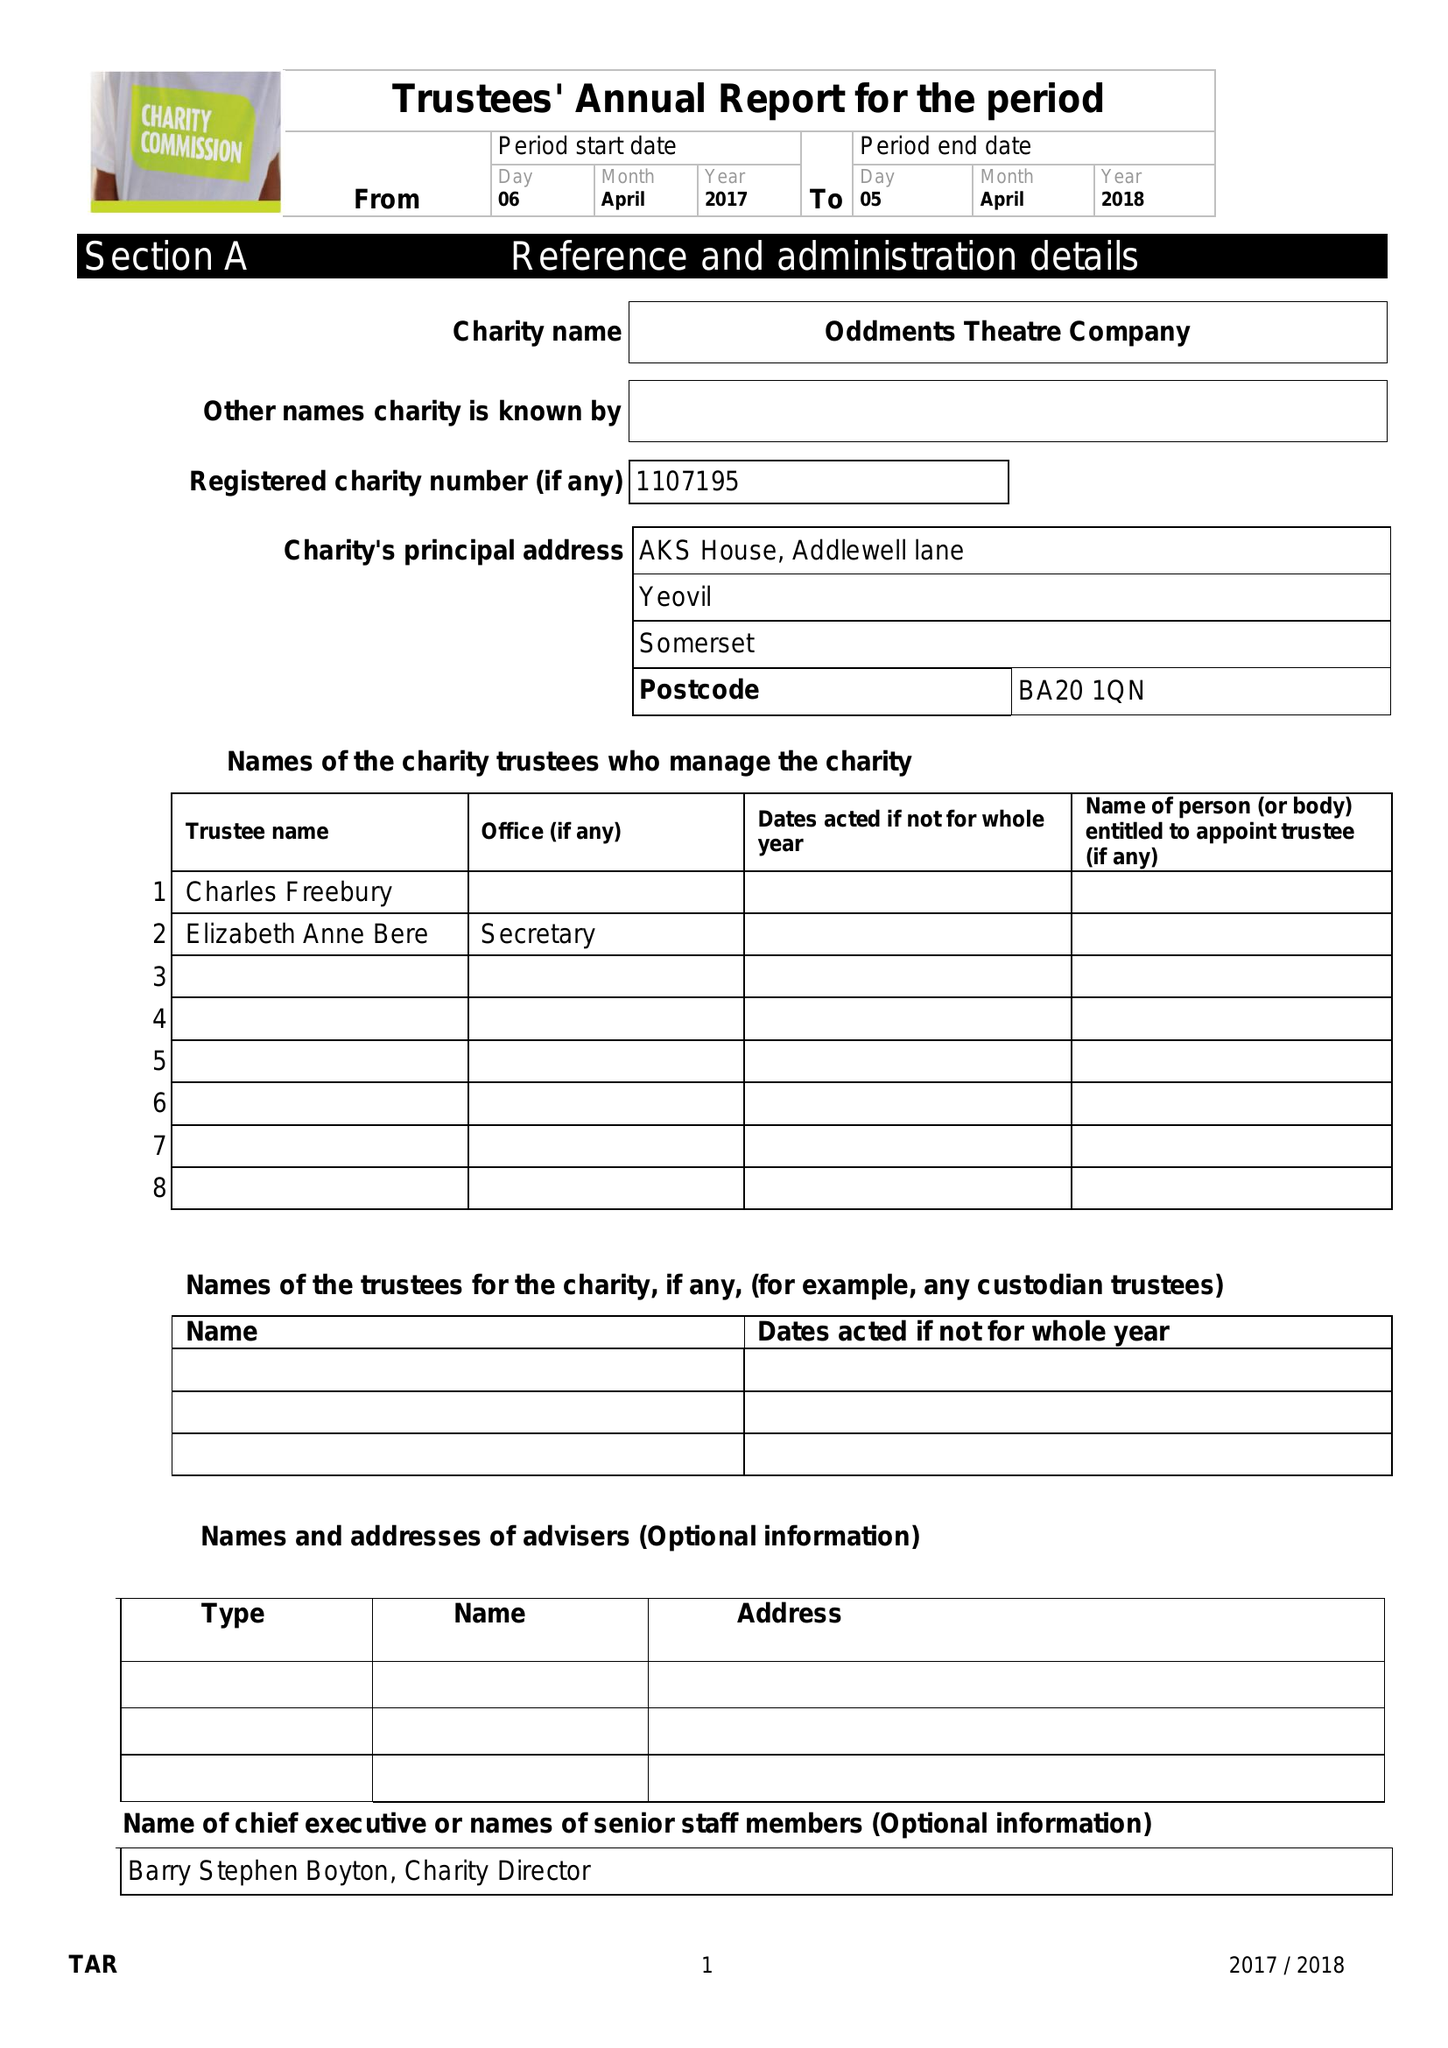What is the value for the charity_name?
Answer the question using a single word or phrase. Oddments Theatre Company 